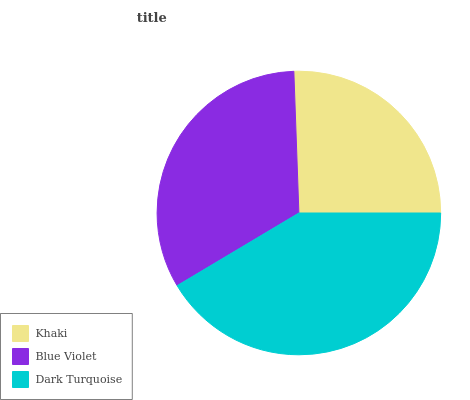Is Khaki the minimum?
Answer yes or no. Yes. Is Dark Turquoise the maximum?
Answer yes or no. Yes. Is Blue Violet the minimum?
Answer yes or no. No. Is Blue Violet the maximum?
Answer yes or no. No. Is Blue Violet greater than Khaki?
Answer yes or no. Yes. Is Khaki less than Blue Violet?
Answer yes or no. Yes. Is Khaki greater than Blue Violet?
Answer yes or no. No. Is Blue Violet less than Khaki?
Answer yes or no. No. Is Blue Violet the high median?
Answer yes or no. Yes. Is Blue Violet the low median?
Answer yes or no. Yes. Is Khaki the high median?
Answer yes or no. No. Is Khaki the low median?
Answer yes or no. No. 